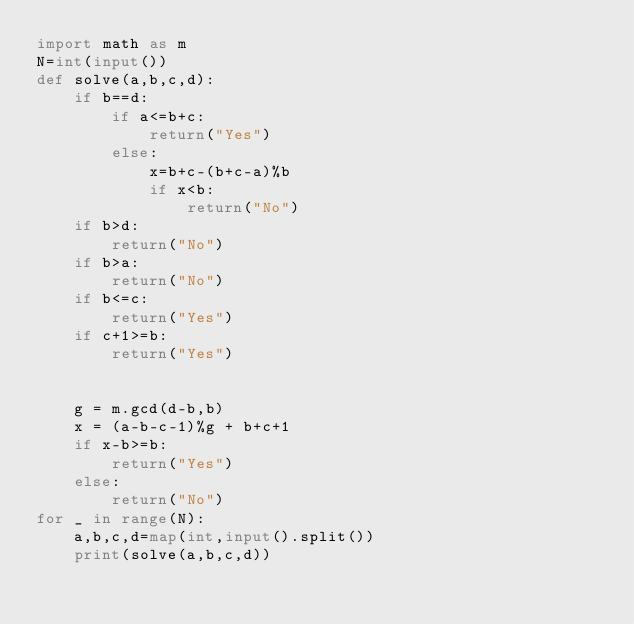Convert code to text. <code><loc_0><loc_0><loc_500><loc_500><_Python_>import math as m
N=int(input())
def solve(a,b,c,d):
    if b==d:
        if a<=b+c:
            return("Yes")
        else:
            x=b+c-(b+c-a)%b
            if x<b:
                return("No")
    if b>d:
        return("No")
    if b>a:
        return("No")
    if b<=c:
        return("Yes")
    if c+1>=b:
        return("Yes")
    
    
    g = m.gcd(d-b,b)
    x = (a-b-c-1)%g + b+c+1
    if x-b>=b:
        return("Yes")
    else:
        return("No")
for _ in range(N):
    a,b,c,d=map(int,input().split())
    print(solve(a,b,c,d))</code> 